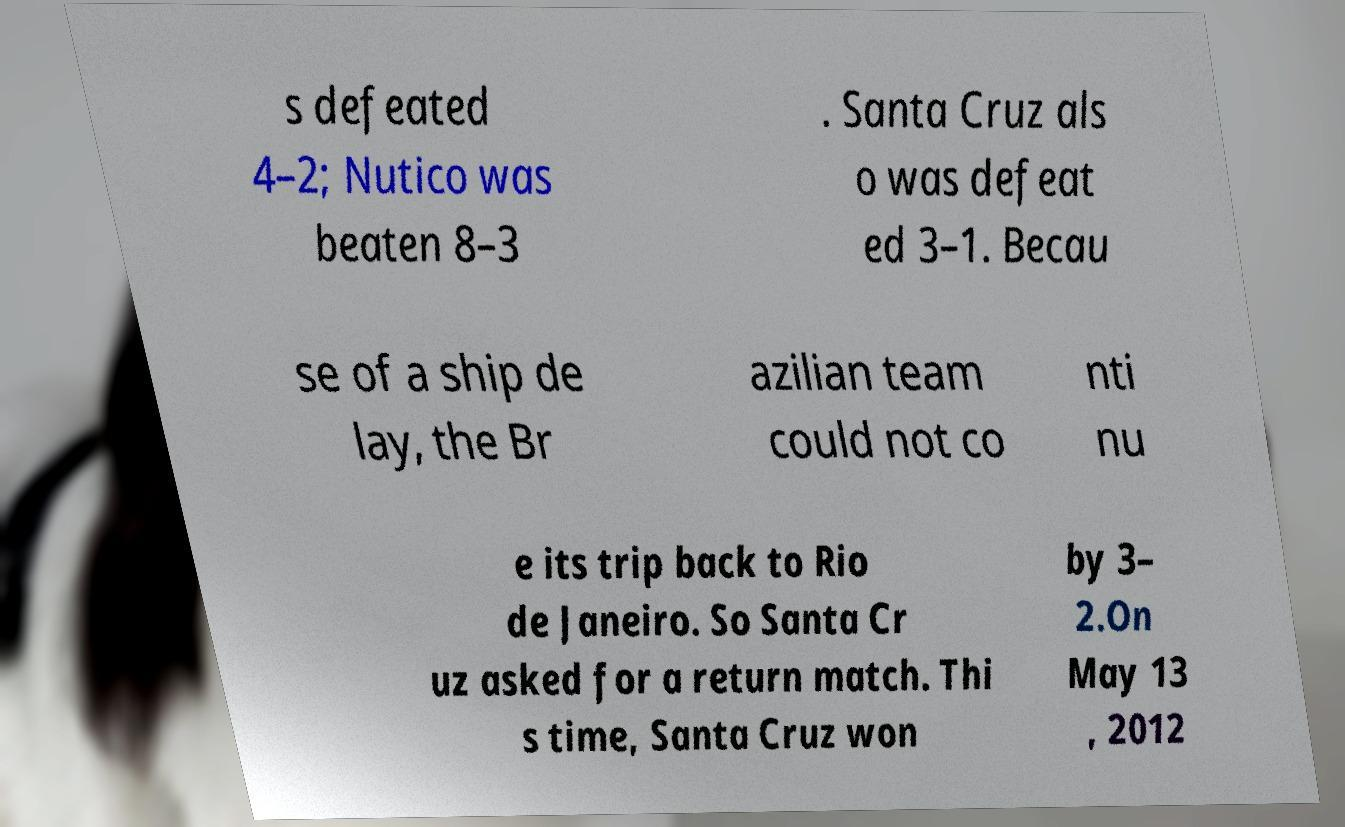There's text embedded in this image that I need extracted. Can you transcribe it verbatim? s defeated 4–2; Nutico was beaten 8–3 . Santa Cruz als o was defeat ed 3–1. Becau se of a ship de lay, the Br azilian team could not co nti nu e its trip back to Rio de Janeiro. So Santa Cr uz asked for a return match. Thi s time, Santa Cruz won by 3– 2.On May 13 , 2012 